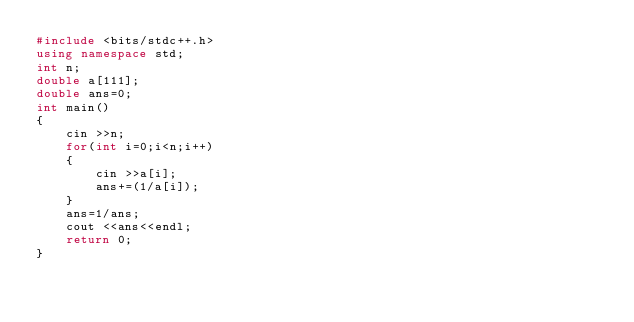<code> <loc_0><loc_0><loc_500><loc_500><_C++_>#include <bits/stdc++.h>
using namespace std;
int n;
double a[111];
double ans=0;
int main()
{
	cin >>n;
	for(int i=0;i<n;i++)
	{
		cin >>a[i];
		ans+=(1/a[i]);
	}
	ans=1/ans;
	cout <<ans<<endl;
	return 0;
}</code> 